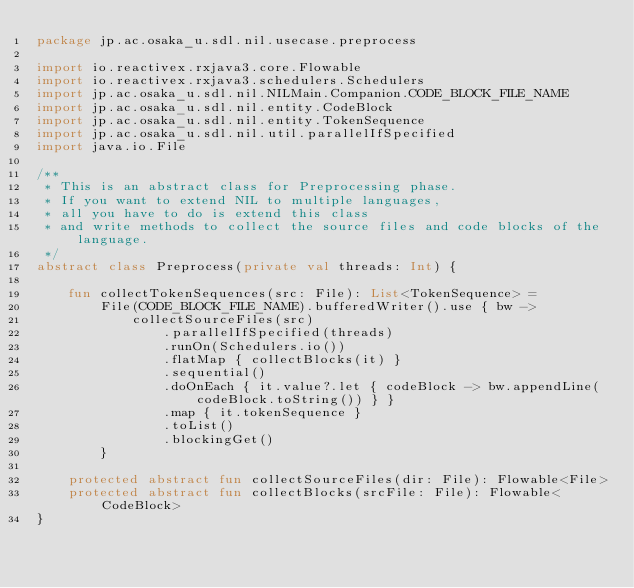<code> <loc_0><loc_0><loc_500><loc_500><_Kotlin_>package jp.ac.osaka_u.sdl.nil.usecase.preprocess

import io.reactivex.rxjava3.core.Flowable
import io.reactivex.rxjava3.schedulers.Schedulers
import jp.ac.osaka_u.sdl.nil.NILMain.Companion.CODE_BLOCK_FILE_NAME
import jp.ac.osaka_u.sdl.nil.entity.CodeBlock
import jp.ac.osaka_u.sdl.nil.entity.TokenSequence
import jp.ac.osaka_u.sdl.nil.util.parallelIfSpecified
import java.io.File

/**
 * This is an abstract class for Preprocessing phase.
 * If you want to extend NIL to multiple languages,
 * all you have to do is extend this class
 * and write methods to collect the source files and code blocks of the language.
 */
abstract class Preprocess(private val threads: Int) {

    fun collectTokenSequences(src: File): List<TokenSequence> =
        File(CODE_BLOCK_FILE_NAME).bufferedWriter().use { bw ->
            collectSourceFiles(src)
                .parallelIfSpecified(threads)
                .runOn(Schedulers.io())
                .flatMap { collectBlocks(it) }
                .sequential()
                .doOnEach { it.value?.let { codeBlock -> bw.appendLine(codeBlock.toString()) } }
                .map { it.tokenSequence }
                .toList()
                .blockingGet()
        }

    protected abstract fun collectSourceFiles(dir: File): Flowable<File>
    protected abstract fun collectBlocks(srcFile: File): Flowable<CodeBlock>
}
</code> 